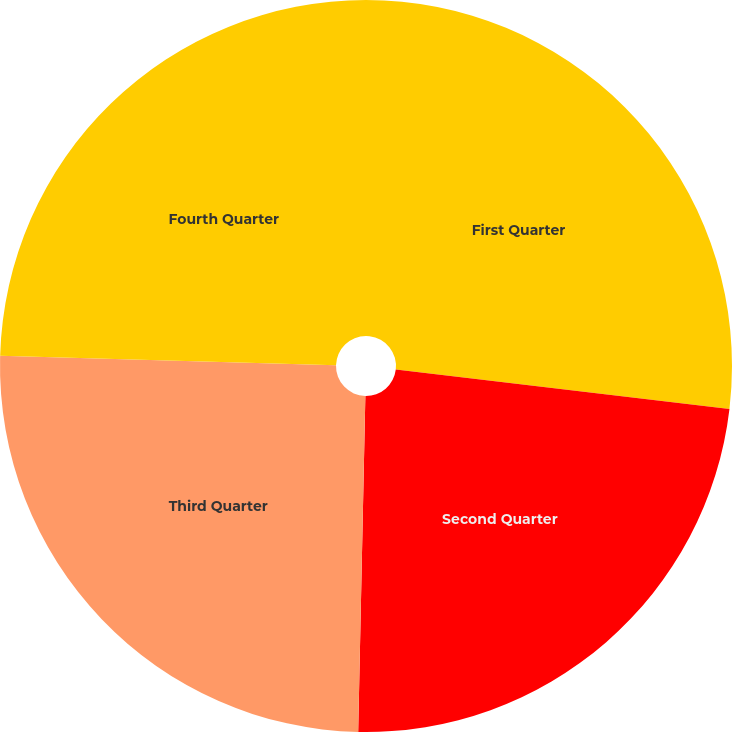Convert chart. <chart><loc_0><loc_0><loc_500><loc_500><pie_chart><fcel>First Quarter<fcel>Second Quarter<fcel>Third Quarter<fcel>Fourth Quarter<nl><fcel>26.87%<fcel>23.47%<fcel>25.11%<fcel>24.55%<nl></chart> 